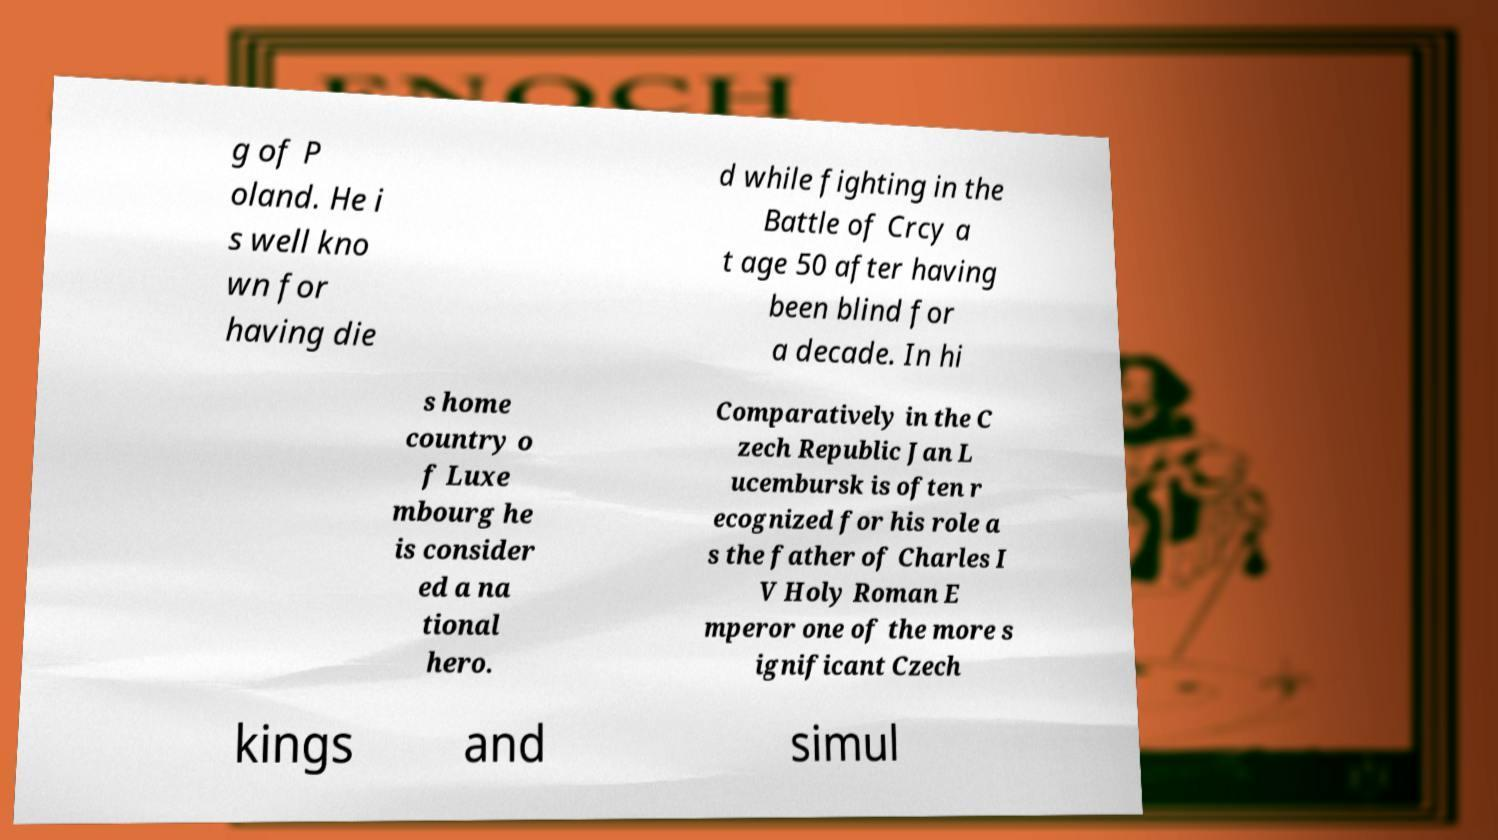Can you accurately transcribe the text from the provided image for me? g of P oland. He i s well kno wn for having die d while fighting in the Battle of Crcy a t age 50 after having been blind for a decade. In hi s home country o f Luxe mbourg he is consider ed a na tional hero. Comparatively in the C zech Republic Jan L ucembursk is often r ecognized for his role a s the father of Charles I V Holy Roman E mperor one of the more s ignificant Czech kings and simul 